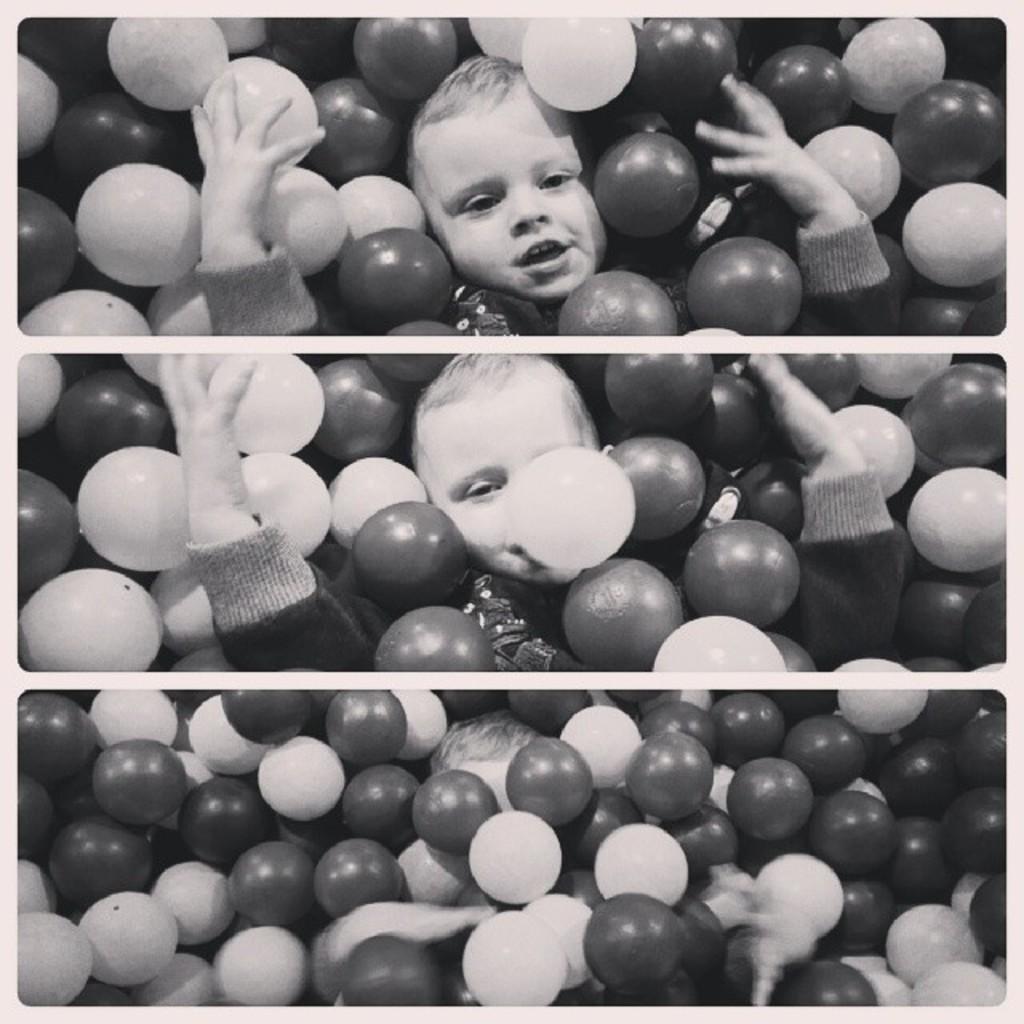How would you summarize this image in a sentence or two? This image is a collage image. There are three image , at top of this image there is one boy is lying and there are some balls at left side to him and some are at right side to him and same as in middle of this image. and in the bottom image as we can see there are some balls and there is a head of a boy at bottom of this image. 